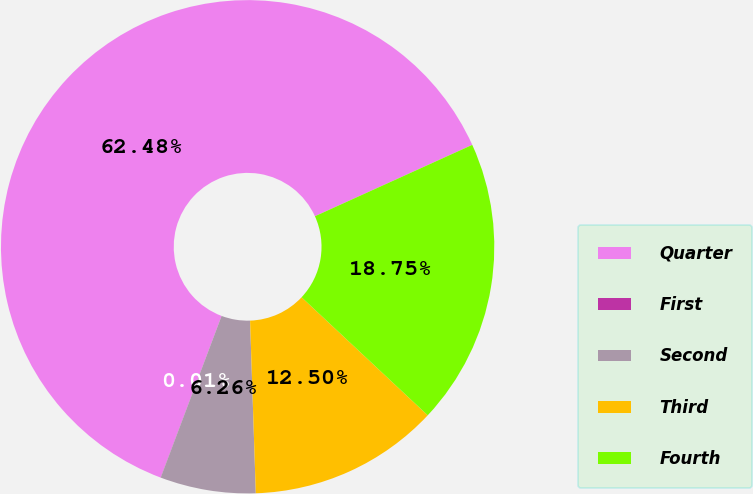Convert chart. <chart><loc_0><loc_0><loc_500><loc_500><pie_chart><fcel>Quarter<fcel>First<fcel>Second<fcel>Third<fcel>Fourth<nl><fcel>62.48%<fcel>0.01%<fcel>6.26%<fcel>12.5%<fcel>18.75%<nl></chart> 